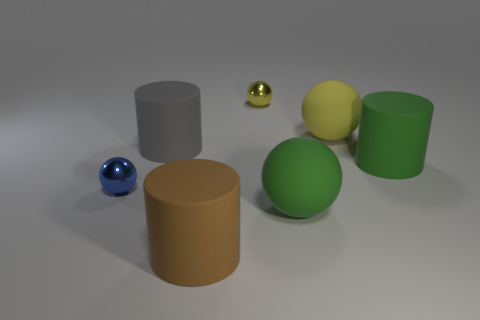Subtract all small blue balls. How many balls are left? 3 Subtract all spheres. How many objects are left? 3 Subtract 2 cylinders. How many cylinders are left? 1 Subtract all yellow balls. How many balls are left? 2 Add 2 green rubber cylinders. How many objects exist? 9 Subtract all brown spheres. Subtract all cyan cylinders. How many spheres are left? 4 Subtract all cyan cylinders. How many purple spheres are left? 0 Subtract all yellow metallic balls. Subtract all gray shiny spheres. How many objects are left? 6 Add 6 big matte spheres. How many big matte spheres are left? 8 Add 4 brown rubber things. How many brown rubber things exist? 5 